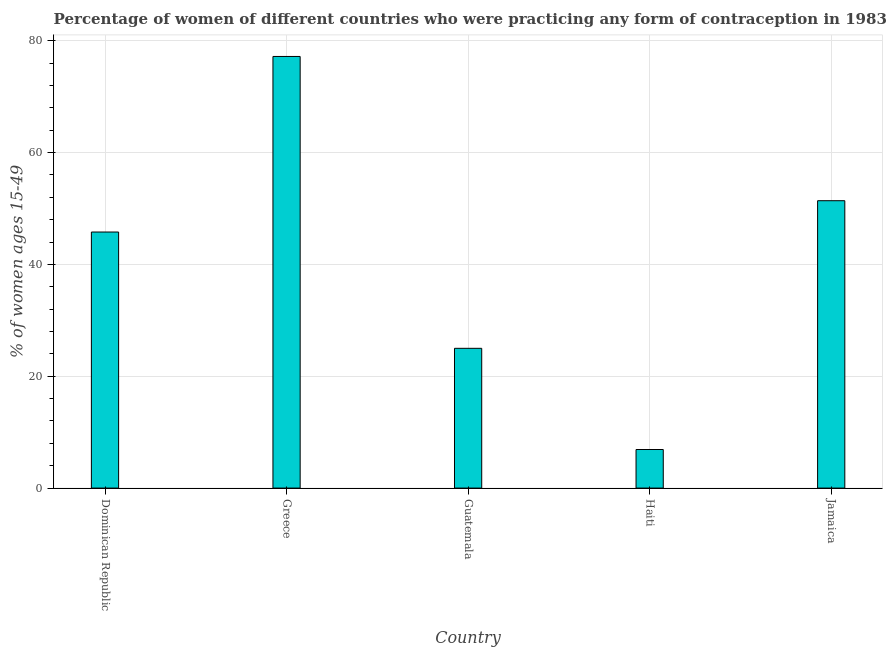Does the graph contain any zero values?
Ensure brevity in your answer.  No. What is the title of the graph?
Provide a succinct answer. Percentage of women of different countries who were practicing any form of contraception in 1983. What is the label or title of the X-axis?
Offer a very short reply. Country. What is the label or title of the Y-axis?
Your response must be concise. % of women ages 15-49. What is the contraceptive prevalence in Greece?
Ensure brevity in your answer.  77.2. Across all countries, what is the maximum contraceptive prevalence?
Make the answer very short. 77.2. In which country was the contraceptive prevalence maximum?
Provide a succinct answer. Greece. In which country was the contraceptive prevalence minimum?
Offer a very short reply. Haiti. What is the sum of the contraceptive prevalence?
Make the answer very short. 206.3. What is the difference between the contraceptive prevalence in Greece and Guatemala?
Your response must be concise. 52.2. What is the average contraceptive prevalence per country?
Make the answer very short. 41.26. What is the median contraceptive prevalence?
Give a very brief answer. 45.8. In how many countries, is the contraceptive prevalence greater than 52 %?
Give a very brief answer. 1. What is the ratio of the contraceptive prevalence in Dominican Republic to that in Greece?
Offer a very short reply. 0.59. Is the contraceptive prevalence in Dominican Republic less than that in Greece?
Ensure brevity in your answer.  Yes. Is the difference between the contraceptive prevalence in Haiti and Jamaica greater than the difference between any two countries?
Give a very brief answer. No. What is the difference between the highest and the second highest contraceptive prevalence?
Offer a very short reply. 25.8. What is the difference between the highest and the lowest contraceptive prevalence?
Your answer should be very brief. 70.3. How many bars are there?
Your answer should be very brief. 5. Are all the bars in the graph horizontal?
Provide a succinct answer. No. How many countries are there in the graph?
Your answer should be very brief. 5. What is the difference between two consecutive major ticks on the Y-axis?
Ensure brevity in your answer.  20. What is the % of women ages 15-49 in Dominican Republic?
Offer a terse response. 45.8. What is the % of women ages 15-49 of Greece?
Offer a terse response. 77.2. What is the % of women ages 15-49 in Haiti?
Offer a very short reply. 6.9. What is the % of women ages 15-49 in Jamaica?
Keep it short and to the point. 51.4. What is the difference between the % of women ages 15-49 in Dominican Republic and Greece?
Your answer should be very brief. -31.4. What is the difference between the % of women ages 15-49 in Dominican Republic and Guatemala?
Provide a succinct answer. 20.8. What is the difference between the % of women ages 15-49 in Dominican Republic and Haiti?
Give a very brief answer. 38.9. What is the difference between the % of women ages 15-49 in Greece and Guatemala?
Keep it short and to the point. 52.2. What is the difference between the % of women ages 15-49 in Greece and Haiti?
Offer a terse response. 70.3. What is the difference between the % of women ages 15-49 in Greece and Jamaica?
Provide a succinct answer. 25.8. What is the difference between the % of women ages 15-49 in Guatemala and Haiti?
Offer a terse response. 18.1. What is the difference between the % of women ages 15-49 in Guatemala and Jamaica?
Your answer should be compact. -26.4. What is the difference between the % of women ages 15-49 in Haiti and Jamaica?
Provide a short and direct response. -44.5. What is the ratio of the % of women ages 15-49 in Dominican Republic to that in Greece?
Your answer should be very brief. 0.59. What is the ratio of the % of women ages 15-49 in Dominican Republic to that in Guatemala?
Provide a short and direct response. 1.83. What is the ratio of the % of women ages 15-49 in Dominican Republic to that in Haiti?
Keep it short and to the point. 6.64. What is the ratio of the % of women ages 15-49 in Dominican Republic to that in Jamaica?
Provide a short and direct response. 0.89. What is the ratio of the % of women ages 15-49 in Greece to that in Guatemala?
Your response must be concise. 3.09. What is the ratio of the % of women ages 15-49 in Greece to that in Haiti?
Offer a very short reply. 11.19. What is the ratio of the % of women ages 15-49 in Greece to that in Jamaica?
Ensure brevity in your answer.  1.5. What is the ratio of the % of women ages 15-49 in Guatemala to that in Haiti?
Keep it short and to the point. 3.62. What is the ratio of the % of women ages 15-49 in Guatemala to that in Jamaica?
Provide a short and direct response. 0.49. What is the ratio of the % of women ages 15-49 in Haiti to that in Jamaica?
Make the answer very short. 0.13. 